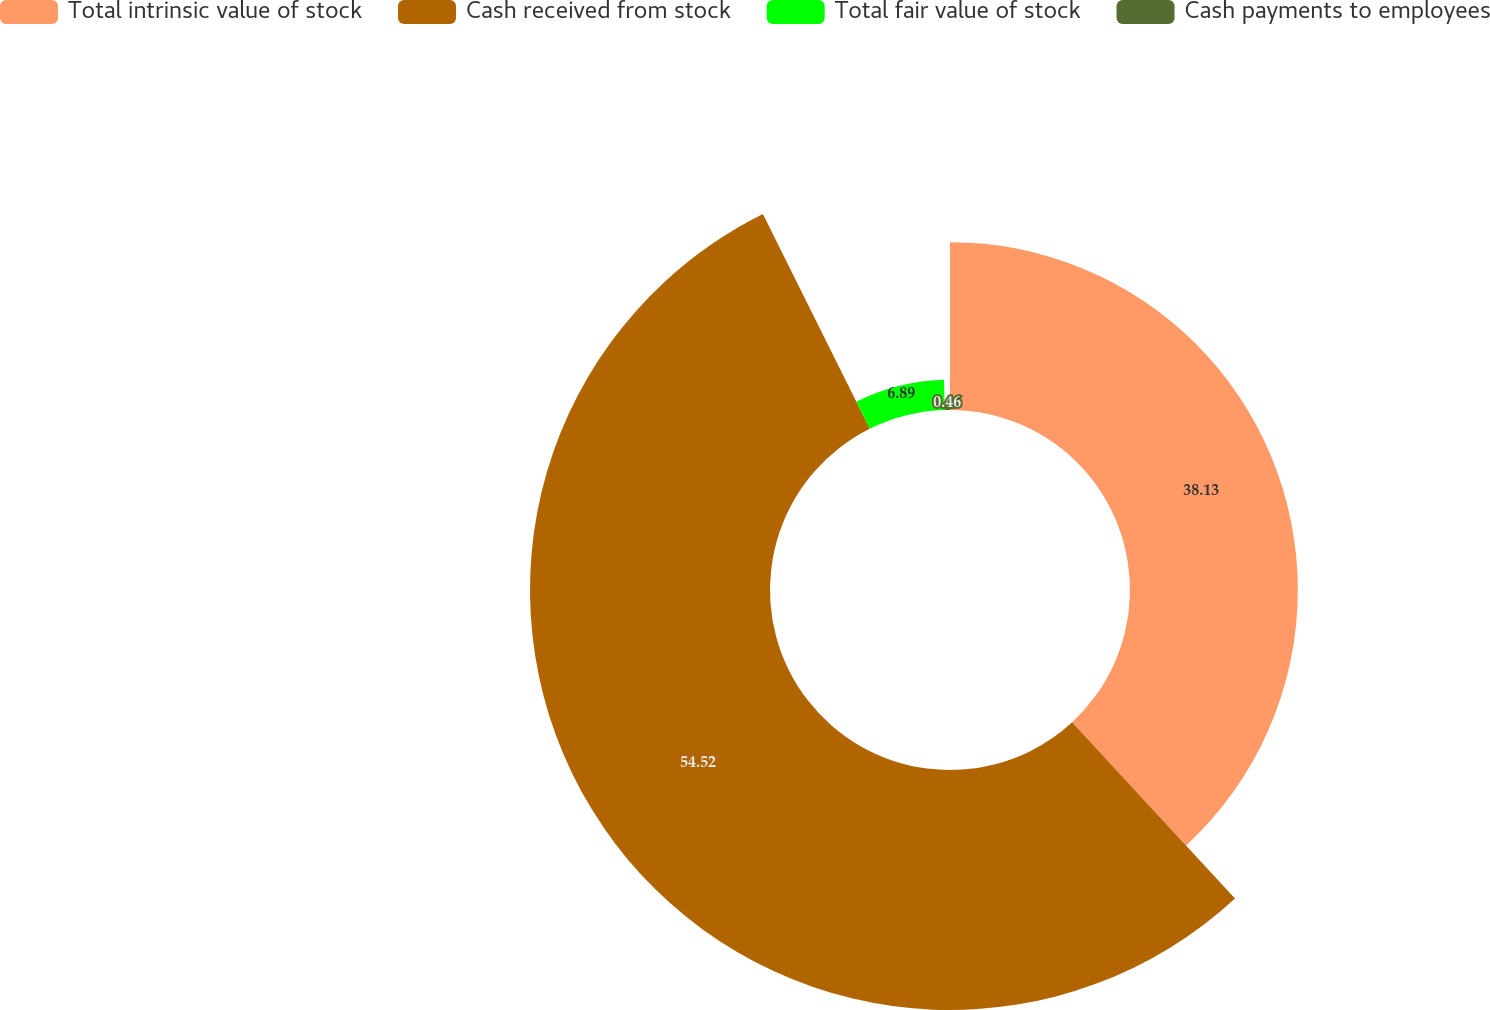<chart> <loc_0><loc_0><loc_500><loc_500><pie_chart><fcel>Total intrinsic value of stock<fcel>Cash received from stock<fcel>Total fair value of stock<fcel>Cash payments to employees<nl><fcel>38.13%<fcel>54.52%<fcel>6.89%<fcel>0.46%<nl></chart> 